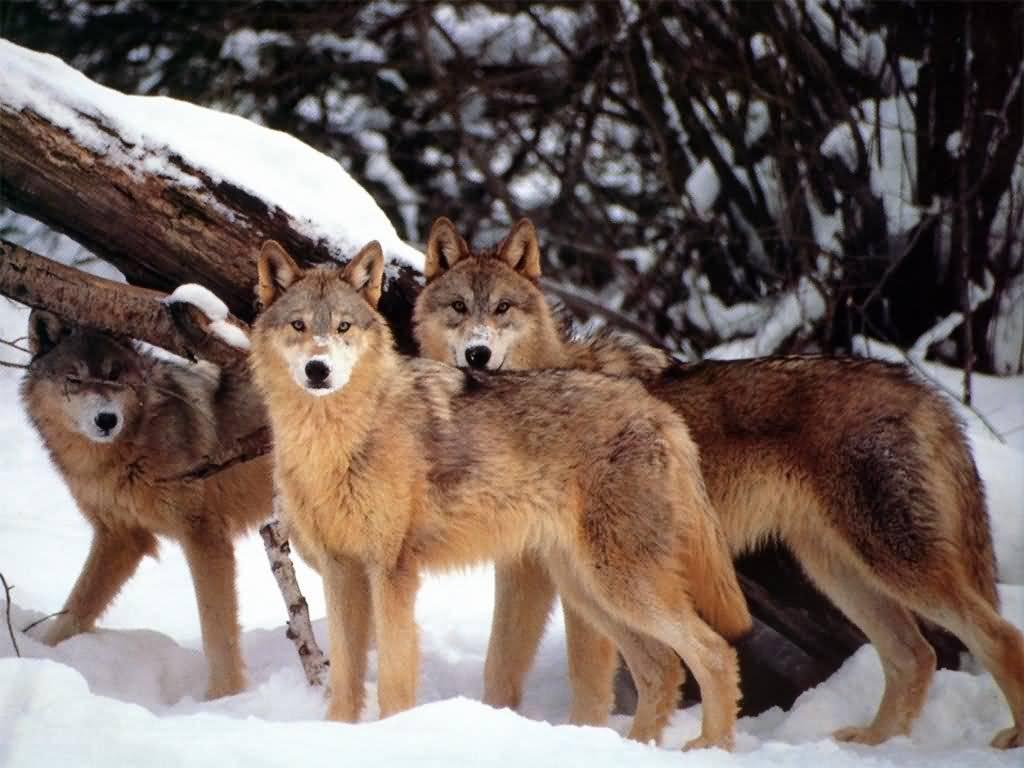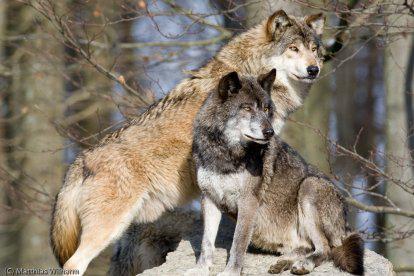The first image is the image on the left, the second image is the image on the right. Analyze the images presented: Is the assertion "The right image contains two or fewer wolves." valid? Answer yes or no. Yes. The first image is the image on the left, the second image is the image on the right. For the images shown, is this caption "An image features exactly three wolves, which look toward the camera." true? Answer yes or no. Yes. 